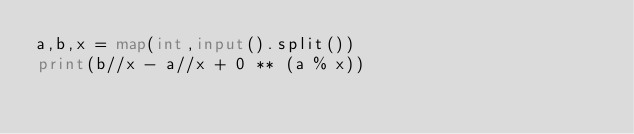Convert code to text. <code><loc_0><loc_0><loc_500><loc_500><_Python_>a,b,x = map(int,input().split())
print(b//x - a//x + 0 ** (a % x))</code> 